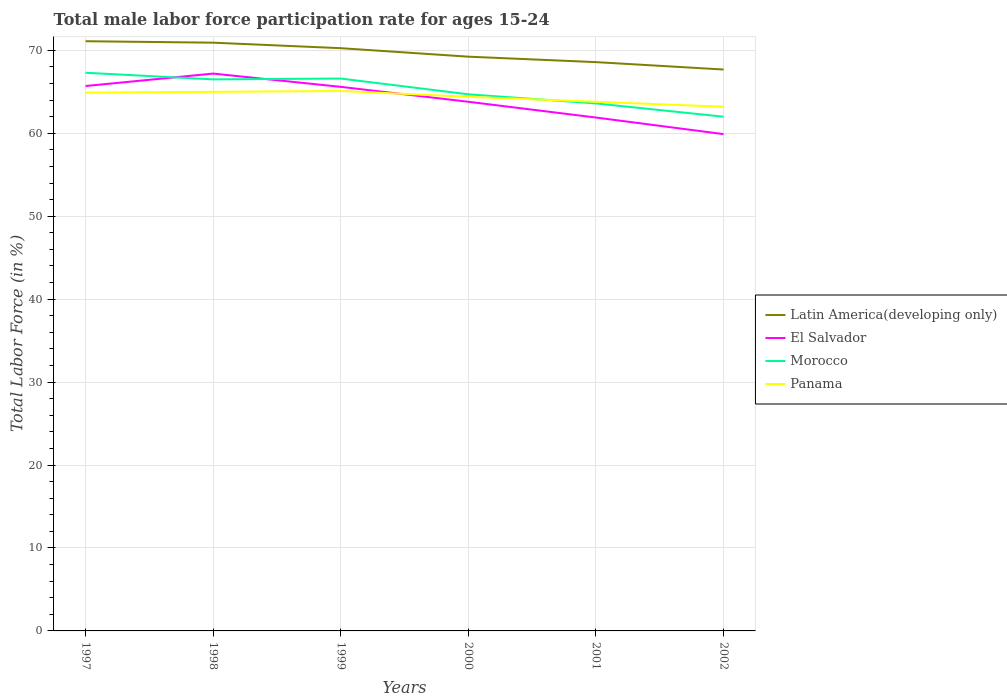Does the line corresponding to Panama intersect with the line corresponding to Morocco?
Provide a succinct answer. Yes. Across all years, what is the maximum male labor force participation rate in Latin America(developing only)?
Offer a terse response. 67.69. What is the total male labor force participation rate in Latin America(developing only) in the graph?
Your response must be concise. 1.68. What is the difference between the highest and the second highest male labor force participation rate in Latin America(developing only)?
Your answer should be very brief. 3.41. How many lines are there?
Offer a very short reply. 4. What is the difference between two consecutive major ticks on the Y-axis?
Your response must be concise. 10. Does the graph contain any zero values?
Make the answer very short. No. Where does the legend appear in the graph?
Your response must be concise. Center right. How many legend labels are there?
Your response must be concise. 4. What is the title of the graph?
Offer a very short reply. Total male labor force participation rate for ages 15-24. What is the label or title of the X-axis?
Provide a succinct answer. Years. What is the Total Labor Force (in %) in Latin America(developing only) in 1997?
Offer a very short reply. 71.1. What is the Total Labor Force (in %) of El Salvador in 1997?
Your response must be concise. 65.7. What is the Total Labor Force (in %) in Morocco in 1997?
Your answer should be compact. 67.3. What is the Total Labor Force (in %) in Panama in 1997?
Provide a succinct answer. 64.9. What is the Total Labor Force (in %) of Latin America(developing only) in 1998?
Provide a short and direct response. 70.93. What is the Total Labor Force (in %) of El Salvador in 1998?
Give a very brief answer. 67.2. What is the Total Labor Force (in %) of Morocco in 1998?
Keep it short and to the point. 66.5. What is the Total Labor Force (in %) of Latin America(developing only) in 1999?
Make the answer very short. 70.26. What is the Total Labor Force (in %) in El Salvador in 1999?
Give a very brief answer. 65.6. What is the Total Labor Force (in %) of Morocco in 1999?
Keep it short and to the point. 66.6. What is the Total Labor Force (in %) in Panama in 1999?
Your response must be concise. 65.1. What is the Total Labor Force (in %) in Latin America(developing only) in 2000?
Offer a terse response. 69.24. What is the Total Labor Force (in %) in El Salvador in 2000?
Ensure brevity in your answer.  63.8. What is the Total Labor Force (in %) of Morocco in 2000?
Give a very brief answer. 64.7. What is the Total Labor Force (in %) of Panama in 2000?
Make the answer very short. 64.4. What is the Total Labor Force (in %) in Latin America(developing only) in 2001?
Provide a succinct answer. 68.58. What is the Total Labor Force (in %) of El Salvador in 2001?
Your answer should be very brief. 61.9. What is the Total Labor Force (in %) of Morocco in 2001?
Keep it short and to the point. 63.6. What is the Total Labor Force (in %) in Panama in 2001?
Keep it short and to the point. 63.8. What is the Total Labor Force (in %) of Latin America(developing only) in 2002?
Provide a succinct answer. 67.69. What is the Total Labor Force (in %) in El Salvador in 2002?
Give a very brief answer. 59.9. What is the Total Labor Force (in %) in Morocco in 2002?
Provide a short and direct response. 62. What is the Total Labor Force (in %) of Panama in 2002?
Make the answer very short. 63.2. Across all years, what is the maximum Total Labor Force (in %) of Latin America(developing only)?
Provide a succinct answer. 71.1. Across all years, what is the maximum Total Labor Force (in %) of El Salvador?
Your answer should be very brief. 67.2. Across all years, what is the maximum Total Labor Force (in %) in Morocco?
Keep it short and to the point. 67.3. Across all years, what is the maximum Total Labor Force (in %) in Panama?
Your response must be concise. 65.1. Across all years, what is the minimum Total Labor Force (in %) in Latin America(developing only)?
Give a very brief answer. 67.69. Across all years, what is the minimum Total Labor Force (in %) in El Salvador?
Your response must be concise. 59.9. Across all years, what is the minimum Total Labor Force (in %) of Morocco?
Offer a very short reply. 62. Across all years, what is the minimum Total Labor Force (in %) in Panama?
Provide a succinct answer. 63.2. What is the total Total Labor Force (in %) in Latin America(developing only) in the graph?
Your answer should be very brief. 417.8. What is the total Total Labor Force (in %) of El Salvador in the graph?
Give a very brief answer. 384.1. What is the total Total Labor Force (in %) in Morocco in the graph?
Keep it short and to the point. 390.7. What is the total Total Labor Force (in %) in Panama in the graph?
Your response must be concise. 386.4. What is the difference between the Total Labor Force (in %) of Latin America(developing only) in 1997 and that in 1998?
Make the answer very short. 0.17. What is the difference between the Total Labor Force (in %) of Morocco in 1997 and that in 1998?
Offer a terse response. 0.8. What is the difference between the Total Labor Force (in %) of Panama in 1997 and that in 1998?
Keep it short and to the point. -0.1. What is the difference between the Total Labor Force (in %) of Latin America(developing only) in 1997 and that in 1999?
Make the answer very short. 0.84. What is the difference between the Total Labor Force (in %) in Latin America(developing only) in 1997 and that in 2000?
Offer a terse response. 1.86. What is the difference between the Total Labor Force (in %) in Morocco in 1997 and that in 2000?
Keep it short and to the point. 2.6. What is the difference between the Total Labor Force (in %) of Latin America(developing only) in 1997 and that in 2001?
Your answer should be compact. 2.52. What is the difference between the Total Labor Force (in %) of Latin America(developing only) in 1997 and that in 2002?
Provide a short and direct response. 3.41. What is the difference between the Total Labor Force (in %) of El Salvador in 1997 and that in 2002?
Your answer should be compact. 5.8. What is the difference between the Total Labor Force (in %) of Morocco in 1997 and that in 2002?
Make the answer very short. 5.3. What is the difference between the Total Labor Force (in %) in Panama in 1997 and that in 2002?
Provide a succinct answer. 1.7. What is the difference between the Total Labor Force (in %) of Latin America(developing only) in 1998 and that in 1999?
Keep it short and to the point. 0.66. What is the difference between the Total Labor Force (in %) of El Salvador in 1998 and that in 1999?
Your response must be concise. 1.6. What is the difference between the Total Labor Force (in %) in Latin America(developing only) in 1998 and that in 2000?
Make the answer very short. 1.69. What is the difference between the Total Labor Force (in %) in Panama in 1998 and that in 2000?
Give a very brief answer. 0.6. What is the difference between the Total Labor Force (in %) in Latin America(developing only) in 1998 and that in 2001?
Offer a very short reply. 2.35. What is the difference between the Total Labor Force (in %) of Morocco in 1998 and that in 2001?
Offer a terse response. 2.9. What is the difference between the Total Labor Force (in %) of Panama in 1998 and that in 2001?
Make the answer very short. 1.2. What is the difference between the Total Labor Force (in %) in Latin America(developing only) in 1998 and that in 2002?
Your answer should be compact. 3.24. What is the difference between the Total Labor Force (in %) of Morocco in 1998 and that in 2002?
Offer a terse response. 4.5. What is the difference between the Total Labor Force (in %) of Latin America(developing only) in 1999 and that in 2000?
Your answer should be compact. 1.02. What is the difference between the Total Labor Force (in %) of Latin America(developing only) in 1999 and that in 2001?
Provide a short and direct response. 1.68. What is the difference between the Total Labor Force (in %) of El Salvador in 1999 and that in 2001?
Keep it short and to the point. 3.7. What is the difference between the Total Labor Force (in %) in Latin America(developing only) in 1999 and that in 2002?
Keep it short and to the point. 2.57. What is the difference between the Total Labor Force (in %) in Morocco in 1999 and that in 2002?
Offer a terse response. 4.6. What is the difference between the Total Labor Force (in %) in Panama in 1999 and that in 2002?
Provide a short and direct response. 1.9. What is the difference between the Total Labor Force (in %) in Latin America(developing only) in 2000 and that in 2001?
Your answer should be compact. 0.66. What is the difference between the Total Labor Force (in %) in El Salvador in 2000 and that in 2001?
Your answer should be compact. 1.9. What is the difference between the Total Labor Force (in %) in Latin America(developing only) in 2000 and that in 2002?
Your answer should be very brief. 1.55. What is the difference between the Total Labor Force (in %) of El Salvador in 2000 and that in 2002?
Your answer should be very brief. 3.9. What is the difference between the Total Labor Force (in %) in Panama in 2000 and that in 2002?
Offer a terse response. 1.2. What is the difference between the Total Labor Force (in %) of Latin America(developing only) in 2001 and that in 2002?
Keep it short and to the point. 0.89. What is the difference between the Total Labor Force (in %) of Panama in 2001 and that in 2002?
Provide a succinct answer. 0.6. What is the difference between the Total Labor Force (in %) in Latin America(developing only) in 1997 and the Total Labor Force (in %) in El Salvador in 1998?
Your answer should be very brief. 3.9. What is the difference between the Total Labor Force (in %) in Latin America(developing only) in 1997 and the Total Labor Force (in %) in Morocco in 1998?
Offer a very short reply. 4.6. What is the difference between the Total Labor Force (in %) in Latin America(developing only) in 1997 and the Total Labor Force (in %) in Panama in 1998?
Give a very brief answer. 6.1. What is the difference between the Total Labor Force (in %) in El Salvador in 1997 and the Total Labor Force (in %) in Panama in 1998?
Offer a very short reply. 0.7. What is the difference between the Total Labor Force (in %) of Latin America(developing only) in 1997 and the Total Labor Force (in %) of El Salvador in 1999?
Your answer should be very brief. 5.5. What is the difference between the Total Labor Force (in %) in Latin America(developing only) in 1997 and the Total Labor Force (in %) in Morocco in 1999?
Your response must be concise. 4.5. What is the difference between the Total Labor Force (in %) in Latin America(developing only) in 1997 and the Total Labor Force (in %) in Panama in 1999?
Keep it short and to the point. 6. What is the difference between the Total Labor Force (in %) in El Salvador in 1997 and the Total Labor Force (in %) in Morocco in 1999?
Provide a short and direct response. -0.9. What is the difference between the Total Labor Force (in %) in El Salvador in 1997 and the Total Labor Force (in %) in Panama in 1999?
Give a very brief answer. 0.6. What is the difference between the Total Labor Force (in %) in Morocco in 1997 and the Total Labor Force (in %) in Panama in 1999?
Give a very brief answer. 2.2. What is the difference between the Total Labor Force (in %) in Latin America(developing only) in 1997 and the Total Labor Force (in %) in El Salvador in 2000?
Your answer should be compact. 7.3. What is the difference between the Total Labor Force (in %) of Latin America(developing only) in 1997 and the Total Labor Force (in %) of Morocco in 2000?
Make the answer very short. 6.4. What is the difference between the Total Labor Force (in %) of Latin America(developing only) in 1997 and the Total Labor Force (in %) of Panama in 2000?
Your response must be concise. 6.7. What is the difference between the Total Labor Force (in %) of El Salvador in 1997 and the Total Labor Force (in %) of Morocco in 2000?
Your response must be concise. 1. What is the difference between the Total Labor Force (in %) in El Salvador in 1997 and the Total Labor Force (in %) in Panama in 2000?
Make the answer very short. 1.3. What is the difference between the Total Labor Force (in %) of Morocco in 1997 and the Total Labor Force (in %) of Panama in 2000?
Give a very brief answer. 2.9. What is the difference between the Total Labor Force (in %) of Latin America(developing only) in 1997 and the Total Labor Force (in %) of El Salvador in 2001?
Give a very brief answer. 9.2. What is the difference between the Total Labor Force (in %) of Latin America(developing only) in 1997 and the Total Labor Force (in %) of Morocco in 2001?
Make the answer very short. 7.5. What is the difference between the Total Labor Force (in %) of Latin America(developing only) in 1997 and the Total Labor Force (in %) of Panama in 2001?
Provide a short and direct response. 7.3. What is the difference between the Total Labor Force (in %) of El Salvador in 1997 and the Total Labor Force (in %) of Panama in 2001?
Give a very brief answer. 1.9. What is the difference between the Total Labor Force (in %) in Morocco in 1997 and the Total Labor Force (in %) in Panama in 2001?
Your answer should be very brief. 3.5. What is the difference between the Total Labor Force (in %) in Latin America(developing only) in 1997 and the Total Labor Force (in %) in El Salvador in 2002?
Your response must be concise. 11.2. What is the difference between the Total Labor Force (in %) of Latin America(developing only) in 1997 and the Total Labor Force (in %) of Morocco in 2002?
Keep it short and to the point. 9.1. What is the difference between the Total Labor Force (in %) in Latin America(developing only) in 1997 and the Total Labor Force (in %) in Panama in 2002?
Provide a short and direct response. 7.9. What is the difference between the Total Labor Force (in %) of El Salvador in 1997 and the Total Labor Force (in %) of Morocco in 2002?
Provide a succinct answer. 3.7. What is the difference between the Total Labor Force (in %) of El Salvador in 1997 and the Total Labor Force (in %) of Panama in 2002?
Provide a succinct answer. 2.5. What is the difference between the Total Labor Force (in %) in Morocco in 1997 and the Total Labor Force (in %) in Panama in 2002?
Keep it short and to the point. 4.1. What is the difference between the Total Labor Force (in %) of Latin America(developing only) in 1998 and the Total Labor Force (in %) of El Salvador in 1999?
Ensure brevity in your answer.  5.33. What is the difference between the Total Labor Force (in %) in Latin America(developing only) in 1998 and the Total Labor Force (in %) in Morocco in 1999?
Provide a short and direct response. 4.33. What is the difference between the Total Labor Force (in %) in Latin America(developing only) in 1998 and the Total Labor Force (in %) in Panama in 1999?
Provide a succinct answer. 5.83. What is the difference between the Total Labor Force (in %) of El Salvador in 1998 and the Total Labor Force (in %) of Panama in 1999?
Ensure brevity in your answer.  2.1. What is the difference between the Total Labor Force (in %) in Morocco in 1998 and the Total Labor Force (in %) in Panama in 1999?
Make the answer very short. 1.4. What is the difference between the Total Labor Force (in %) of Latin America(developing only) in 1998 and the Total Labor Force (in %) of El Salvador in 2000?
Offer a terse response. 7.13. What is the difference between the Total Labor Force (in %) in Latin America(developing only) in 1998 and the Total Labor Force (in %) in Morocco in 2000?
Offer a terse response. 6.23. What is the difference between the Total Labor Force (in %) of Latin America(developing only) in 1998 and the Total Labor Force (in %) of Panama in 2000?
Your answer should be compact. 6.53. What is the difference between the Total Labor Force (in %) of El Salvador in 1998 and the Total Labor Force (in %) of Morocco in 2000?
Offer a very short reply. 2.5. What is the difference between the Total Labor Force (in %) of El Salvador in 1998 and the Total Labor Force (in %) of Panama in 2000?
Offer a terse response. 2.8. What is the difference between the Total Labor Force (in %) of Morocco in 1998 and the Total Labor Force (in %) of Panama in 2000?
Give a very brief answer. 2.1. What is the difference between the Total Labor Force (in %) in Latin America(developing only) in 1998 and the Total Labor Force (in %) in El Salvador in 2001?
Keep it short and to the point. 9.03. What is the difference between the Total Labor Force (in %) of Latin America(developing only) in 1998 and the Total Labor Force (in %) of Morocco in 2001?
Offer a terse response. 7.33. What is the difference between the Total Labor Force (in %) in Latin America(developing only) in 1998 and the Total Labor Force (in %) in Panama in 2001?
Provide a short and direct response. 7.13. What is the difference between the Total Labor Force (in %) of Morocco in 1998 and the Total Labor Force (in %) of Panama in 2001?
Make the answer very short. 2.7. What is the difference between the Total Labor Force (in %) of Latin America(developing only) in 1998 and the Total Labor Force (in %) of El Salvador in 2002?
Your response must be concise. 11.03. What is the difference between the Total Labor Force (in %) of Latin America(developing only) in 1998 and the Total Labor Force (in %) of Morocco in 2002?
Your answer should be compact. 8.93. What is the difference between the Total Labor Force (in %) of Latin America(developing only) in 1998 and the Total Labor Force (in %) of Panama in 2002?
Give a very brief answer. 7.73. What is the difference between the Total Labor Force (in %) of El Salvador in 1998 and the Total Labor Force (in %) of Morocco in 2002?
Offer a very short reply. 5.2. What is the difference between the Total Labor Force (in %) of El Salvador in 1998 and the Total Labor Force (in %) of Panama in 2002?
Offer a terse response. 4. What is the difference between the Total Labor Force (in %) of Morocco in 1998 and the Total Labor Force (in %) of Panama in 2002?
Your answer should be very brief. 3.3. What is the difference between the Total Labor Force (in %) of Latin America(developing only) in 1999 and the Total Labor Force (in %) of El Salvador in 2000?
Your response must be concise. 6.46. What is the difference between the Total Labor Force (in %) of Latin America(developing only) in 1999 and the Total Labor Force (in %) of Morocco in 2000?
Provide a succinct answer. 5.56. What is the difference between the Total Labor Force (in %) of Latin America(developing only) in 1999 and the Total Labor Force (in %) of Panama in 2000?
Give a very brief answer. 5.86. What is the difference between the Total Labor Force (in %) in El Salvador in 1999 and the Total Labor Force (in %) in Morocco in 2000?
Provide a succinct answer. 0.9. What is the difference between the Total Labor Force (in %) in Morocco in 1999 and the Total Labor Force (in %) in Panama in 2000?
Keep it short and to the point. 2.2. What is the difference between the Total Labor Force (in %) in Latin America(developing only) in 1999 and the Total Labor Force (in %) in El Salvador in 2001?
Offer a terse response. 8.36. What is the difference between the Total Labor Force (in %) of Latin America(developing only) in 1999 and the Total Labor Force (in %) of Morocco in 2001?
Ensure brevity in your answer.  6.66. What is the difference between the Total Labor Force (in %) of Latin America(developing only) in 1999 and the Total Labor Force (in %) of Panama in 2001?
Your answer should be very brief. 6.46. What is the difference between the Total Labor Force (in %) in Morocco in 1999 and the Total Labor Force (in %) in Panama in 2001?
Make the answer very short. 2.8. What is the difference between the Total Labor Force (in %) of Latin America(developing only) in 1999 and the Total Labor Force (in %) of El Salvador in 2002?
Provide a short and direct response. 10.36. What is the difference between the Total Labor Force (in %) of Latin America(developing only) in 1999 and the Total Labor Force (in %) of Morocco in 2002?
Offer a terse response. 8.26. What is the difference between the Total Labor Force (in %) in Latin America(developing only) in 1999 and the Total Labor Force (in %) in Panama in 2002?
Keep it short and to the point. 7.06. What is the difference between the Total Labor Force (in %) in El Salvador in 1999 and the Total Labor Force (in %) in Panama in 2002?
Offer a very short reply. 2.4. What is the difference between the Total Labor Force (in %) in Latin America(developing only) in 2000 and the Total Labor Force (in %) in El Salvador in 2001?
Your answer should be very brief. 7.34. What is the difference between the Total Labor Force (in %) of Latin America(developing only) in 2000 and the Total Labor Force (in %) of Morocco in 2001?
Keep it short and to the point. 5.64. What is the difference between the Total Labor Force (in %) in Latin America(developing only) in 2000 and the Total Labor Force (in %) in Panama in 2001?
Your response must be concise. 5.44. What is the difference between the Total Labor Force (in %) of El Salvador in 2000 and the Total Labor Force (in %) of Panama in 2001?
Offer a very short reply. 0. What is the difference between the Total Labor Force (in %) in Latin America(developing only) in 2000 and the Total Labor Force (in %) in El Salvador in 2002?
Ensure brevity in your answer.  9.34. What is the difference between the Total Labor Force (in %) of Latin America(developing only) in 2000 and the Total Labor Force (in %) of Morocco in 2002?
Ensure brevity in your answer.  7.24. What is the difference between the Total Labor Force (in %) of Latin America(developing only) in 2000 and the Total Labor Force (in %) of Panama in 2002?
Offer a terse response. 6.04. What is the difference between the Total Labor Force (in %) in El Salvador in 2000 and the Total Labor Force (in %) in Morocco in 2002?
Offer a very short reply. 1.8. What is the difference between the Total Labor Force (in %) in El Salvador in 2000 and the Total Labor Force (in %) in Panama in 2002?
Provide a short and direct response. 0.6. What is the difference between the Total Labor Force (in %) in Morocco in 2000 and the Total Labor Force (in %) in Panama in 2002?
Make the answer very short. 1.5. What is the difference between the Total Labor Force (in %) in Latin America(developing only) in 2001 and the Total Labor Force (in %) in El Salvador in 2002?
Your response must be concise. 8.68. What is the difference between the Total Labor Force (in %) of Latin America(developing only) in 2001 and the Total Labor Force (in %) of Morocco in 2002?
Provide a short and direct response. 6.58. What is the difference between the Total Labor Force (in %) in Latin America(developing only) in 2001 and the Total Labor Force (in %) in Panama in 2002?
Offer a terse response. 5.38. What is the difference between the Total Labor Force (in %) in El Salvador in 2001 and the Total Labor Force (in %) in Panama in 2002?
Your response must be concise. -1.3. What is the difference between the Total Labor Force (in %) of Morocco in 2001 and the Total Labor Force (in %) of Panama in 2002?
Offer a terse response. 0.4. What is the average Total Labor Force (in %) in Latin America(developing only) per year?
Provide a succinct answer. 69.63. What is the average Total Labor Force (in %) of El Salvador per year?
Offer a terse response. 64.02. What is the average Total Labor Force (in %) of Morocco per year?
Keep it short and to the point. 65.12. What is the average Total Labor Force (in %) in Panama per year?
Offer a terse response. 64.4. In the year 1997, what is the difference between the Total Labor Force (in %) in Latin America(developing only) and Total Labor Force (in %) in El Salvador?
Provide a short and direct response. 5.4. In the year 1997, what is the difference between the Total Labor Force (in %) in Latin America(developing only) and Total Labor Force (in %) in Morocco?
Keep it short and to the point. 3.8. In the year 1997, what is the difference between the Total Labor Force (in %) of Latin America(developing only) and Total Labor Force (in %) of Panama?
Provide a short and direct response. 6.2. In the year 1997, what is the difference between the Total Labor Force (in %) of El Salvador and Total Labor Force (in %) of Morocco?
Give a very brief answer. -1.6. In the year 1997, what is the difference between the Total Labor Force (in %) of El Salvador and Total Labor Force (in %) of Panama?
Offer a terse response. 0.8. In the year 1998, what is the difference between the Total Labor Force (in %) of Latin America(developing only) and Total Labor Force (in %) of El Salvador?
Offer a very short reply. 3.73. In the year 1998, what is the difference between the Total Labor Force (in %) in Latin America(developing only) and Total Labor Force (in %) in Morocco?
Make the answer very short. 4.43. In the year 1998, what is the difference between the Total Labor Force (in %) of Latin America(developing only) and Total Labor Force (in %) of Panama?
Provide a succinct answer. 5.93. In the year 1998, what is the difference between the Total Labor Force (in %) in El Salvador and Total Labor Force (in %) in Panama?
Your answer should be compact. 2.2. In the year 1999, what is the difference between the Total Labor Force (in %) in Latin America(developing only) and Total Labor Force (in %) in El Salvador?
Provide a succinct answer. 4.66. In the year 1999, what is the difference between the Total Labor Force (in %) in Latin America(developing only) and Total Labor Force (in %) in Morocco?
Offer a very short reply. 3.66. In the year 1999, what is the difference between the Total Labor Force (in %) in Latin America(developing only) and Total Labor Force (in %) in Panama?
Your answer should be compact. 5.16. In the year 2000, what is the difference between the Total Labor Force (in %) in Latin America(developing only) and Total Labor Force (in %) in El Salvador?
Your response must be concise. 5.44. In the year 2000, what is the difference between the Total Labor Force (in %) of Latin America(developing only) and Total Labor Force (in %) of Morocco?
Your answer should be compact. 4.54. In the year 2000, what is the difference between the Total Labor Force (in %) in Latin America(developing only) and Total Labor Force (in %) in Panama?
Provide a succinct answer. 4.84. In the year 2000, what is the difference between the Total Labor Force (in %) of El Salvador and Total Labor Force (in %) of Morocco?
Offer a very short reply. -0.9. In the year 2000, what is the difference between the Total Labor Force (in %) of El Salvador and Total Labor Force (in %) of Panama?
Ensure brevity in your answer.  -0.6. In the year 2000, what is the difference between the Total Labor Force (in %) in Morocco and Total Labor Force (in %) in Panama?
Give a very brief answer. 0.3. In the year 2001, what is the difference between the Total Labor Force (in %) in Latin America(developing only) and Total Labor Force (in %) in El Salvador?
Keep it short and to the point. 6.68. In the year 2001, what is the difference between the Total Labor Force (in %) of Latin America(developing only) and Total Labor Force (in %) of Morocco?
Give a very brief answer. 4.98. In the year 2001, what is the difference between the Total Labor Force (in %) in Latin America(developing only) and Total Labor Force (in %) in Panama?
Your answer should be very brief. 4.78. In the year 2001, what is the difference between the Total Labor Force (in %) in El Salvador and Total Labor Force (in %) in Morocco?
Provide a succinct answer. -1.7. In the year 2001, what is the difference between the Total Labor Force (in %) in Morocco and Total Labor Force (in %) in Panama?
Provide a succinct answer. -0.2. In the year 2002, what is the difference between the Total Labor Force (in %) of Latin America(developing only) and Total Labor Force (in %) of El Salvador?
Make the answer very short. 7.79. In the year 2002, what is the difference between the Total Labor Force (in %) in Latin America(developing only) and Total Labor Force (in %) in Morocco?
Your response must be concise. 5.69. In the year 2002, what is the difference between the Total Labor Force (in %) of Latin America(developing only) and Total Labor Force (in %) of Panama?
Provide a succinct answer. 4.49. In the year 2002, what is the difference between the Total Labor Force (in %) of El Salvador and Total Labor Force (in %) of Morocco?
Your answer should be very brief. -2.1. In the year 2002, what is the difference between the Total Labor Force (in %) in Morocco and Total Labor Force (in %) in Panama?
Your response must be concise. -1.2. What is the ratio of the Total Labor Force (in %) in Latin America(developing only) in 1997 to that in 1998?
Your answer should be very brief. 1. What is the ratio of the Total Labor Force (in %) of El Salvador in 1997 to that in 1998?
Give a very brief answer. 0.98. What is the ratio of the Total Labor Force (in %) in Latin America(developing only) in 1997 to that in 1999?
Your answer should be very brief. 1.01. What is the ratio of the Total Labor Force (in %) of Morocco in 1997 to that in 1999?
Give a very brief answer. 1.01. What is the ratio of the Total Labor Force (in %) of Latin America(developing only) in 1997 to that in 2000?
Offer a terse response. 1.03. What is the ratio of the Total Labor Force (in %) of El Salvador in 1997 to that in 2000?
Make the answer very short. 1.03. What is the ratio of the Total Labor Force (in %) of Morocco in 1997 to that in 2000?
Offer a very short reply. 1.04. What is the ratio of the Total Labor Force (in %) in Panama in 1997 to that in 2000?
Your answer should be compact. 1.01. What is the ratio of the Total Labor Force (in %) of Latin America(developing only) in 1997 to that in 2001?
Keep it short and to the point. 1.04. What is the ratio of the Total Labor Force (in %) of El Salvador in 1997 to that in 2001?
Your answer should be very brief. 1.06. What is the ratio of the Total Labor Force (in %) in Morocco in 1997 to that in 2001?
Make the answer very short. 1.06. What is the ratio of the Total Labor Force (in %) in Panama in 1997 to that in 2001?
Give a very brief answer. 1.02. What is the ratio of the Total Labor Force (in %) of Latin America(developing only) in 1997 to that in 2002?
Make the answer very short. 1.05. What is the ratio of the Total Labor Force (in %) of El Salvador in 1997 to that in 2002?
Your answer should be compact. 1.1. What is the ratio of the Total Labor Force (in %) of Morocco in 1997 to that in 2002?
Ensure brevity in your answer.  1.09. What is the ratio of the Total Labor Force (in %) in Panama in 1997 to that in 2002?
Your answer should be compact. 1.03. What is the ratio of the Total Labor Force (in %) in Latin America(developing only) in 1998 to that in 1999?
Your answer should be compact. 1.01. What is the ratio of the Total Labor Force (in %) in El Salvador in 1998 to that in 1999?
Give a very brief answer. 1.02. What is the ratio of the Total Labor Force (in %) of Morocco in 1998 to that in 1999?
Offer a very short reply. 1. What is the ratio of the Total Labor Force (in %) of Latin America(developing only) in 1998 to that in 2000?
Ensure brevity in your answer.  1.02. What is the ratio of the Total Labor Force (in %) of El Salvador in 1998 to that in 2000?
Offer a very short reply. 1.05. What is the ratio of the Total Labor Force (in %) in Morocco in 1998 to that in 2000?
Give a very brief answer. 1.03. What is the ratio of the Total Labor Force (in %) in Panama in 1998 to that in 2000?
Provide a succinct answer. 1.01. What is the ratio of the Total Labor Force (in %) in Latin America(developing only) in 1998 to that in 2001?
Offer a very short reply. 1.03. What is the ratio of the Total Labor Force (in %) of El Salvador in 1998 to that in 2001?
Ensure brevity in your answer.  1.09. What is the ratio of the Total Labor Force (in %) of Morocco in 1998 to that in 2001?
Keep it short and to the point. 1.05. What is the ratio of the Total Labor Force (in %) of Panama in 1998 to that in 2001?
Provide a short and direct response. 1.02. What is the ratio of the Total Labor Force (in %) of Latin America(developing only) in 1998 to that in 2002?
Give a very brief answer. 1.05. What is the ratio of the Total Labor Force (in %) of El Salvador in 1998 to that in 2002?
Your response must be concise. 1.12. What is the ratio of the Total Labor Force (in %) of Morocco in 1998 to that in 2002?
Ensure brevity in your answer.  1.07. What is the ratio of the Total Labor Force (in %) of Panama in 1998 to that in 2002?
Give a very brief answer. 1.03. What is the ratio of the Total Labor Force (in %) of Latin America(developing only) in 1999 to that in 2000?
Offer a terse response. 1.01. What is the ratio of the Total Labor Force (in %) in El Salvador in 1999 to that in 2000?
Provide a succinct answer. 1.03. What is the ratio of the Total Labor Force (in %) of Morocco in 1999 to that in 2000?
Keep it short and to the point. 1.03. What is the ratio of the Total Labor Force (in %) in Panama in 1999 to that in 2000?
Ensure brevity in your answer.  1.01. What is the ratio of the Total Labor Force (in %) of Latin America(developing only) in 1999 to that in 2001?
Make the answer very short. 1.02. What is the ratio of the Total Labor Force (in %) of El Salvador in 1999 to that in 2001?
Your answer should be compact. 1.06. What is the ratio of the Total Labor Force (in %) in Morocco in 1999 to that in 2001?
Give a very brief answer. 1.05. What is the ratio of the Total Labor Force (in %) in Panama in 1999 to that in 2001?
Give a very brief answer. 1.02. What is the ratio of the Total Labor Force (in %) in Latin America(developing only) in 1999 to that in 2002?
Provide a succinct answer. 1.04. What is the ratio of the Total Labor Force (in %) of El Salvador in 1999 to that in 2002?
Provide a short and direct response. 1.1. What is the ratio of the Total Labor Force (in %) of Morocco in 1999 to that in 2002?
Offer a terse response. 1.07. What is the ratio of the Total Labor Force (in %) in Panama in 1999 to that in 2002?
Ensure brevity in your answer.  1.03. What is the ratio of the Total Labor Force (in %) in Latin America(developing only) in 2000 to that in 2001?
Your response must be concise. 1.01. What is the ratio of the Total Labor Force (in %) of El Salvador in 2000 to that in 2001?
Provide a short and direct response. 1.03. What is the ratio of the Total Labor Force (in %) in Morocco in 2000 to that in 2001?
Provide a short and direct response. 1.02. What is the ratio of the Total Labor Force (in %) of Panama in 2000 to that in 2001?
Your answer should be compact. 1.01. What is the ratio of the Total Labor Force (in %) in Latin America(developing only) in 2000 to that in 2002?
Provide a short and direct response. 1.02. What is the ratio of the Total Labor Force (in %) of El Salvador in 2000 to that in 2002?
Provide a short and direct response. 1.07. What is the ratio of the Total Labor Force (in %) in Morocco in 2000 to that in 2002?
Keep it short and to the point. 1.04. What is the ratio of the Total Labor Force (in %) of Latin America(developing only) in 2001 to that in 2002?
Your answer should be very brief. 1.01. What is the ratio of the Total Labor Force (in %) in El Salvador in 2001 to that in 2002?
Give a very brief answer. 1.03. What is the ratio of the Total Labor Force (in %) in Morocco in 2001 to that in 2002?
Provide a short and direct response. 1.03. What is the ratio of the Total Labor Force (in %) of Panama in 2001 to that in 2002?
Provide a short and direct response. 1.01. What is the difference between the highest and the second highest Total Labor Force (in %) of Latin America(developing only)?
Make the answer very short. 0.17. What is the difference between the highest and the second highest Total Labor Force (in %) of El Salvador?
Make the answer very short. 1.5. What is the difference between the highest and the second highest Total Labor Force (in %) in Morocco?
Give a very brief answer. 0.7. What is the difference between the highest and the second highest Total Labor Force (in %) of Panama?
Provide a succinct answer. 0.1. What is the difference between the highest and the lowest Total Labor Force (in %) in Latin America(developing only)?
Ensure brevity in your answer.  3.41. What is the difference between the highest and the lowest Total Labor Force (in %) of El Salvador?
Your response must be concise. 7.3. What is the difference between the highest and the lowest Total Labor Force (in %) of Panama?
Give a very brief answer. 1.9. 